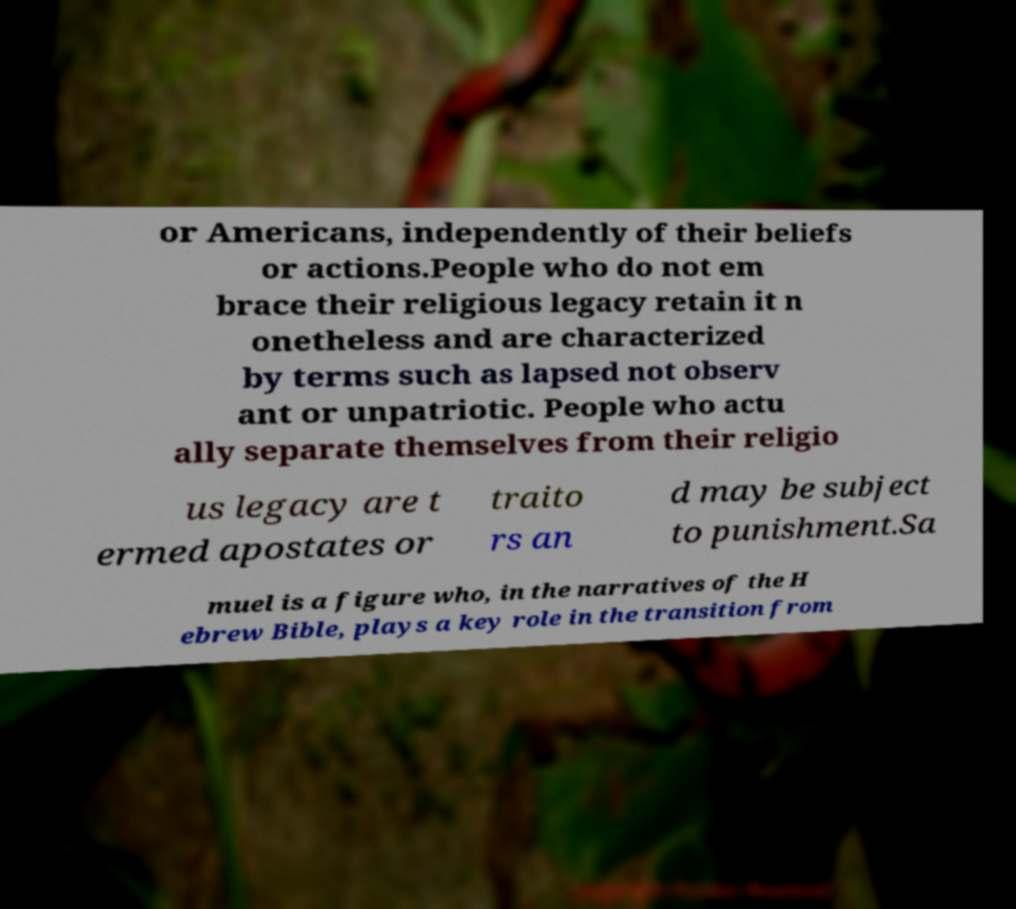For documentation purposes, I need the text within this image transcribed. Could you provide that? or Americans, independently of their beliefs or actions.People who do not em brace their religious legacy retain it n onetheless and are characterized by terms such as lapsed not observ ant or unpatriotic. People who actu ally separate themselves from their religio us legacy are t ermed apostates or traito rs an d may be subject to punishment.Sa muel is a figure who, in the narratives of the H ebrew Bible, plays a key role in the transition from 